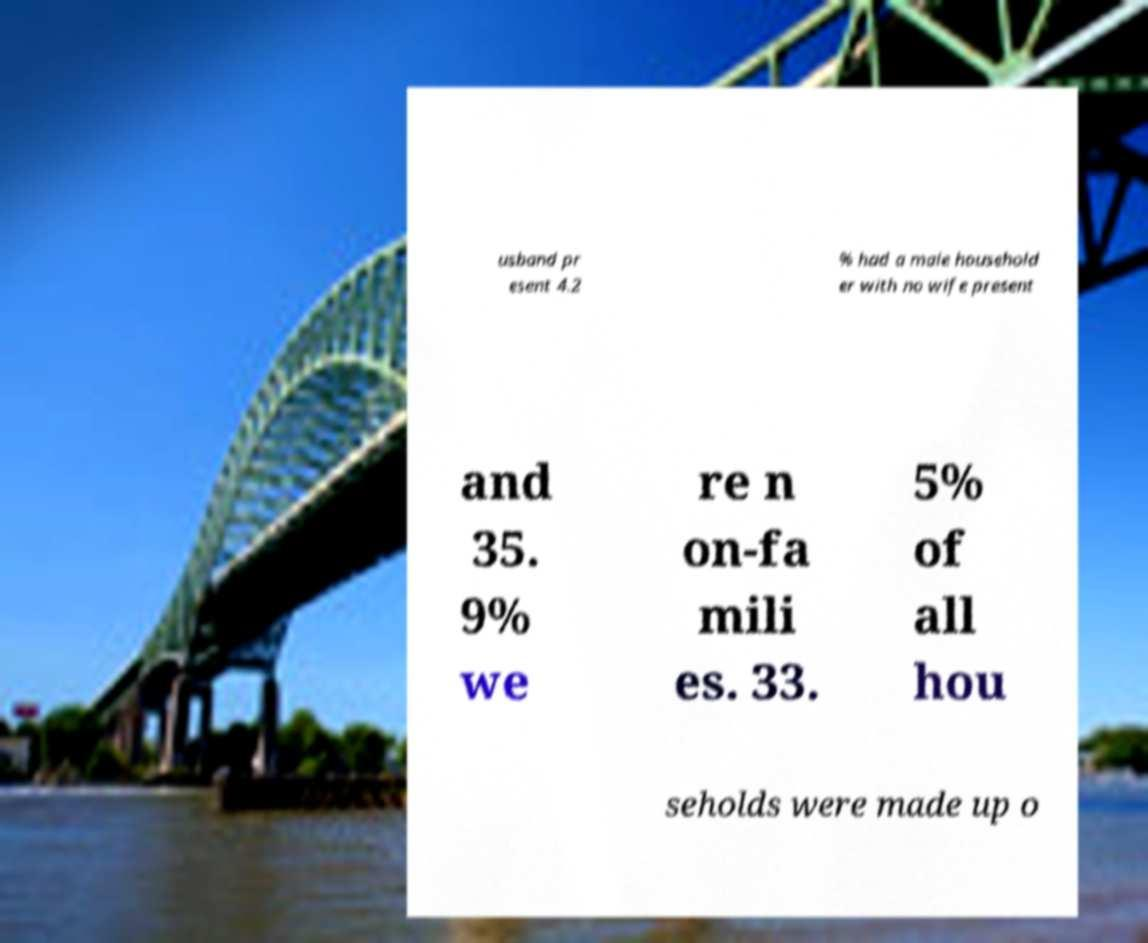Can you accurately transcribe the text from the provided image for me? usband pr esent 4.2 % had a male household er with no wife present and 35. 9% we re n on-fa mili es. 33. 5% of all hou seholds were made up o 